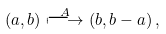Convert formula to latex. <formula><loc_0><loc_0><loc_500><loc_500>\left ( a , b \right ) \overset { A } { \longmapsto } \left ( b , b - a \right ) ,</formula> 